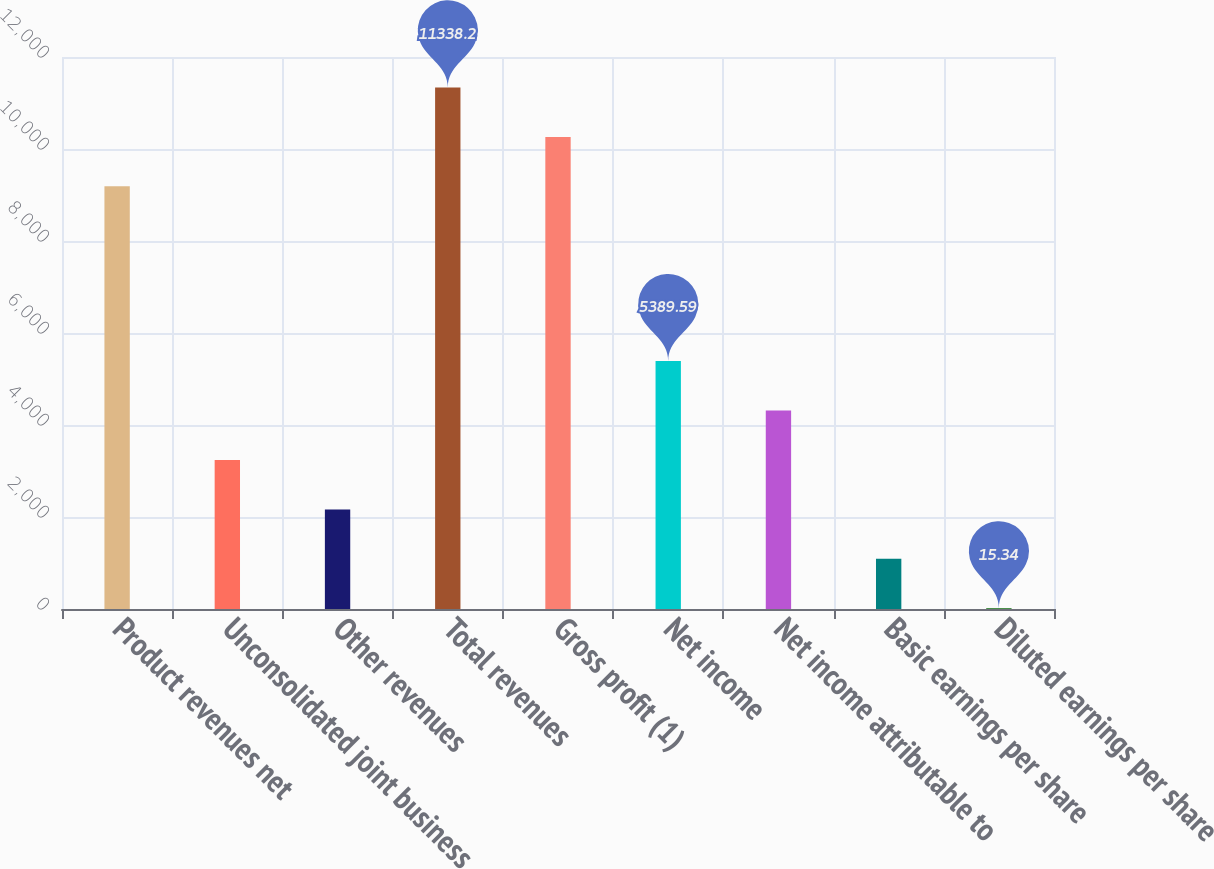Convert chart. <chart><loc_0><loc_0><loc_500><loc_500><bar_chart><fcel>Product revenues net<fcel>Unconsolidated joint business<fcel>Other revenues<fcel>Total revenues<fcel>Gross profit (1)<fcel>Net income<fcel>Net income attributable to<fcel>Basic earnings per share<fcel>Diluted earnings per share<nl><fcel>9188.5<fcel>3239.89<fcel>2165.04<fcel>11338.2<fcel>10263.4<fcel>5389.59<fcel>4314.74<fcel>1090.19<fcel>15.34<nl></chart> 